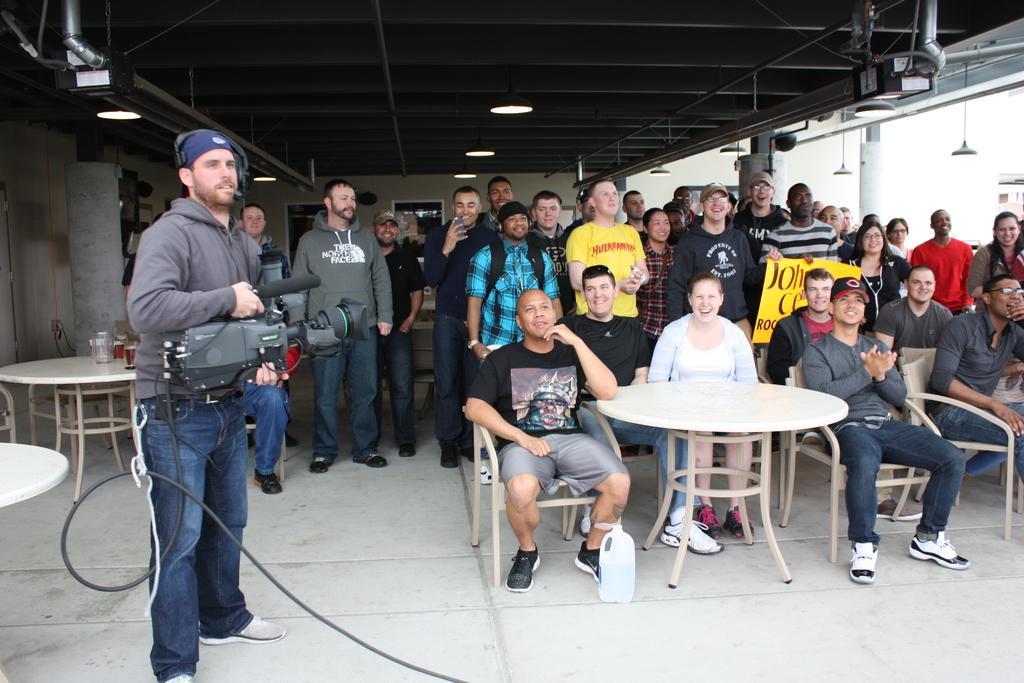In one or two sentences, can you explain what this image depicts? Here we can see a group of people sitting on chairs and there are other group of people standing behind them with a table in front of them and on the left side we can see a person standing and recording in his video camera wearing headphones and there are other tables and chairs also present 